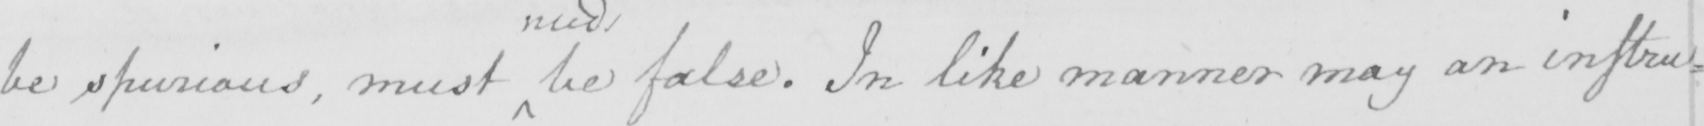Can you read and transcribe this handwriting? be spurious , must be false . In like manner may an instru= 